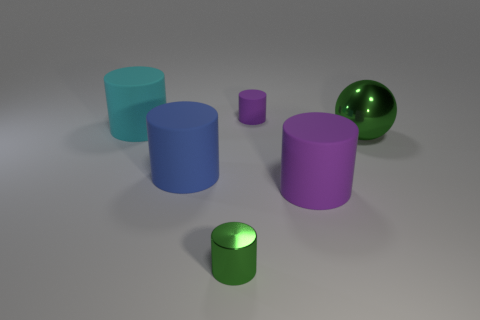The tiny rubber object that is the same shape as the big purple object is what color?
Ensure brevity in your answer.  Purple. Is there any other thing that is the same shape as the large metal object?
Your answer should be compact. No. Does the tiny green object have the same shape as the purple matte object that is behind the big ball?
Your answer should be very brief. Yes. What is the large ball made of?
Provide a succinct answer. Metal. What size is the metallic object that is the same shape as the blue matte thing?
Provide a short and direct response. Small. How many other objects are there of the same material as the big purple cylinder?
Offer a very short reply. 3. Does the tiny green object have the same material as the green object right of the small green shiny thing?
Your answer should be compact. Yes. Is the number of green shiny cylinders that are on the right side of the small purple matte cylinder less than the number of large cyan rubber cylinders that are in front of the cyan matte object?
Your answer should be compact. No. There is a big matte thing right of the green metal cylinder; what is its color?
Your response must be concise. Purple. How many other objects are there of the same color as the ball?
Offer a terse response. 1. 